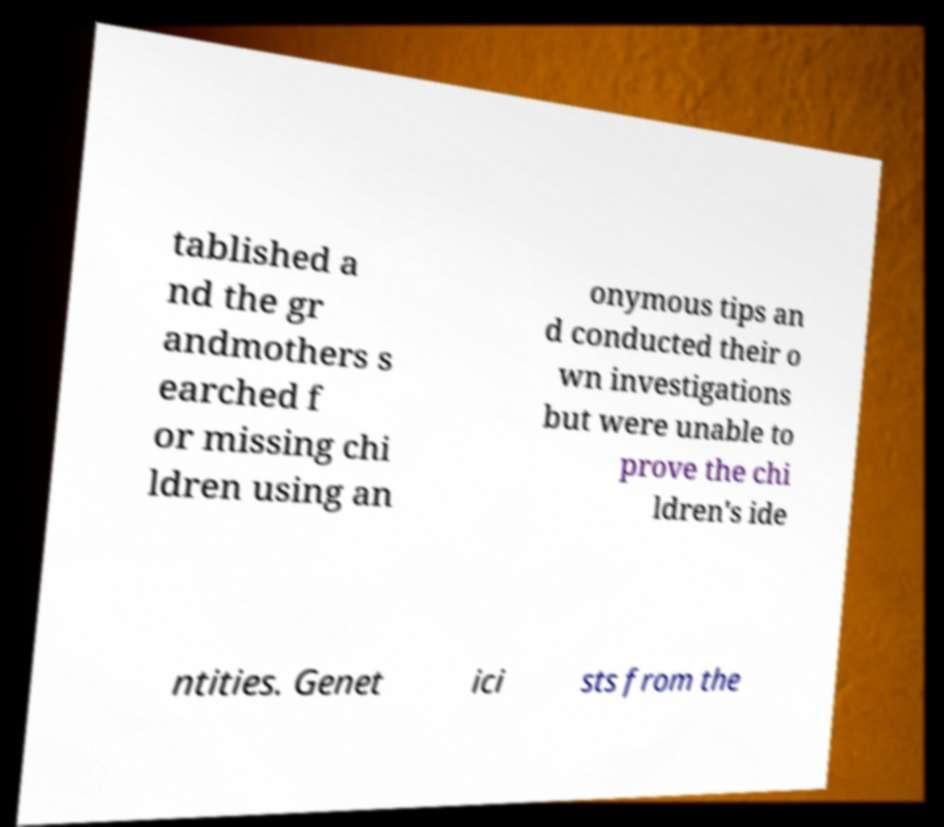I need the written content from this picture converted into text. Can you do that? tablished a nd the gr andmothers s earched f or missing chi ldren using an onymous tips an d conducted their o wn investigations but were unable to prove the chi ldren's ide ntities. Genet ici sts from the 